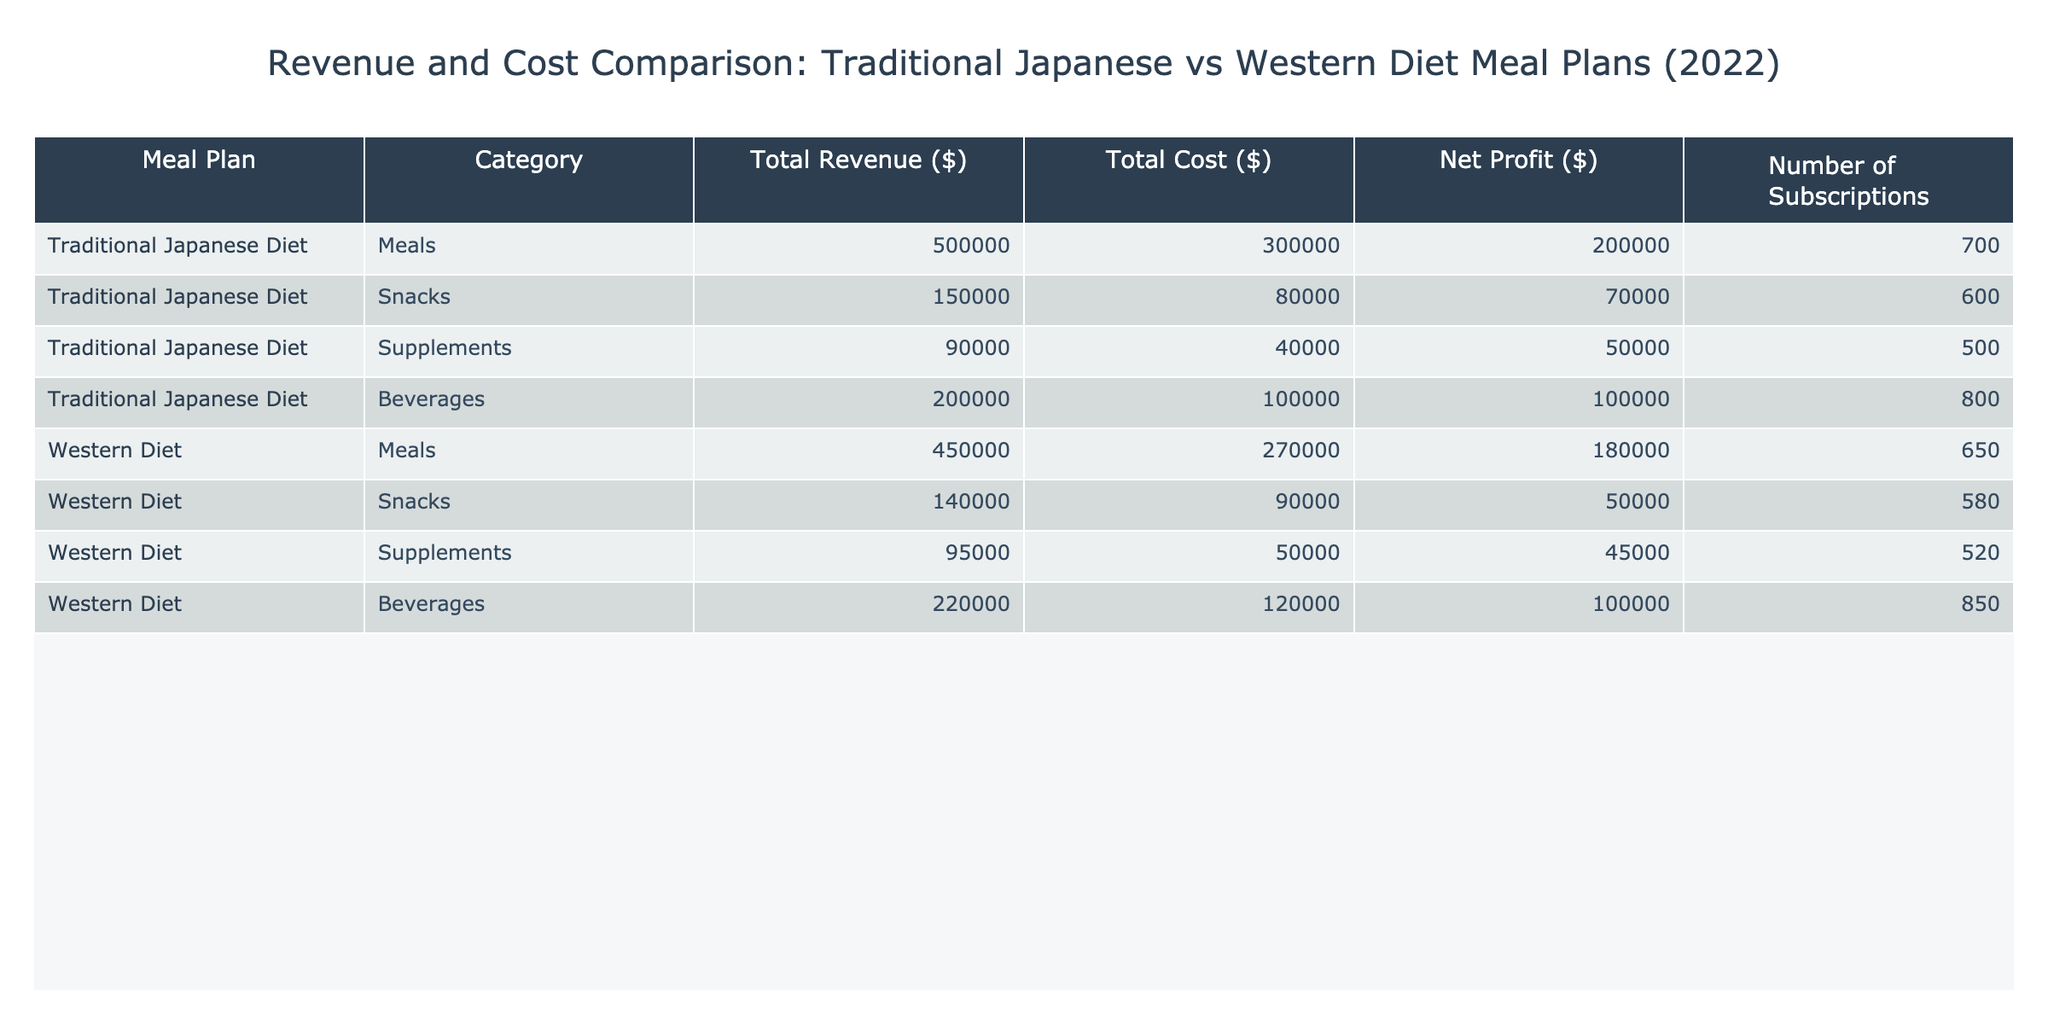What is the total revenue generated by the Traditional Japanese Diet for snacks? Looking at the table, under the "Traditional Japanese Diet" row, the revenue for the "Snacks" category is listed as $150,000.
Answer: 150000 What is the net profit for the Western Diet beverages? The table shows that the net profit for the "Beverages" category under the Western Diet is $100,000.
Answer: 100000 Which diet had a higher total revenue overall? To determine which diet had a higher total revenue, we add up the revenues for each diet. Traditional Japanese Diet total revenue is $500,000 + $150,000 + $90,000 + $200,000 = $940,000. The Western Diet total revenue is $450,000 + $140,000 + $95,000 + $220,000 = $905,000. Therefore, the Traditional Japanese Diet had a higher total revenue.
Answer: Traditional Japanese Diet What is the average cost of meals across both diets? First, we find the cost of meals for both diets: Traditional Japanese Diet meals cost $300,000, and Western Diet meals cost $270,000. We then add these costs: $300,000 + $270,000 = $570,000. Next, we divide by the number of meal plan categories (2) to find the average: $570,000 / 2 = $285,000.
Answer: 285000 Is it true that all categories of the Traditional Japanese Diet offer a net profit greater than $50,000? We examine the net profits for each category under the Traditional Japanese Diet: Meals $200,000, Snacks $70,000, Supplements $50,000, and Beverages $100,000. The Supplements category shows a net profit exactly equal to $50,000 but not greater, thus the statement is false.
Answer: No Which meal plan category has the highest number of subscriptions in the Traditional Japanese Diet? Looking at the number of subscriptions for the Traditional Japanese Diet categories, Meals have 700, Snacks have 600, Supplements have 500, and Beverages have 800. The Beverages category has the highest number of subscriptions.
Answer: Beverages What is the total cost for snacks across both diets? The cost for snacks in the Traditional Japanese Diet is $80,000, and for the Western Diet, it is $90,000. We add these costs together: $80,000 + $90,000 = $170,000.
Answer: 170000 What is the difference in net profit between the Traditional Japanese Diet meals and Western Diet meals? The net profit for Traditional Japanese Diet meals is $200,000, and for Western Diet meals, it is $180,000. The difference is $200,000 - $180,000 = $20,000.
Answer: 20000 Which diet had the lower total cost in beverages? From the table, the cost of beverages for the Traditional Japanese Diet is $100,000 and for the Western Diet is $120,000. Since $100,000 is less than $120,000, the Traditional Japanese Diet had the lower total cost in beverages.
Answer: Traditional Japanese Diet 